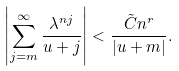Convert formula to latex. <formula><loc_0><loc_0><loc_500><loc_500>\left | \sum _ { j = m } ^ { \infty } \frac { \lambda ^ { n j } } { u + j } \right | < \frac { \tilde { C } n ^ { r } } { | u + m | } .</formula> 